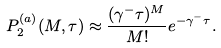Convert formula to latex. <formula><loc_0><loc_0><loc_500><loc_500>P ^ { ( a ) } _ { 2 } ( M , \tau ) \approx \frac { ( \gamma ^ { - } \tau ) ^ { M } } { M ! } e ^ { - \gamma ^ { - } \tau } .</formula> 